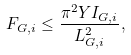Convert formula to latex. <formula><loc_0><loc_0><loc_500><loc_500>F _ { G , i } \leq \frac { \pi ^ { 2 } Y I _ { G , i } } { L _ { G , i } ^ { 2 } } ,</formula> 